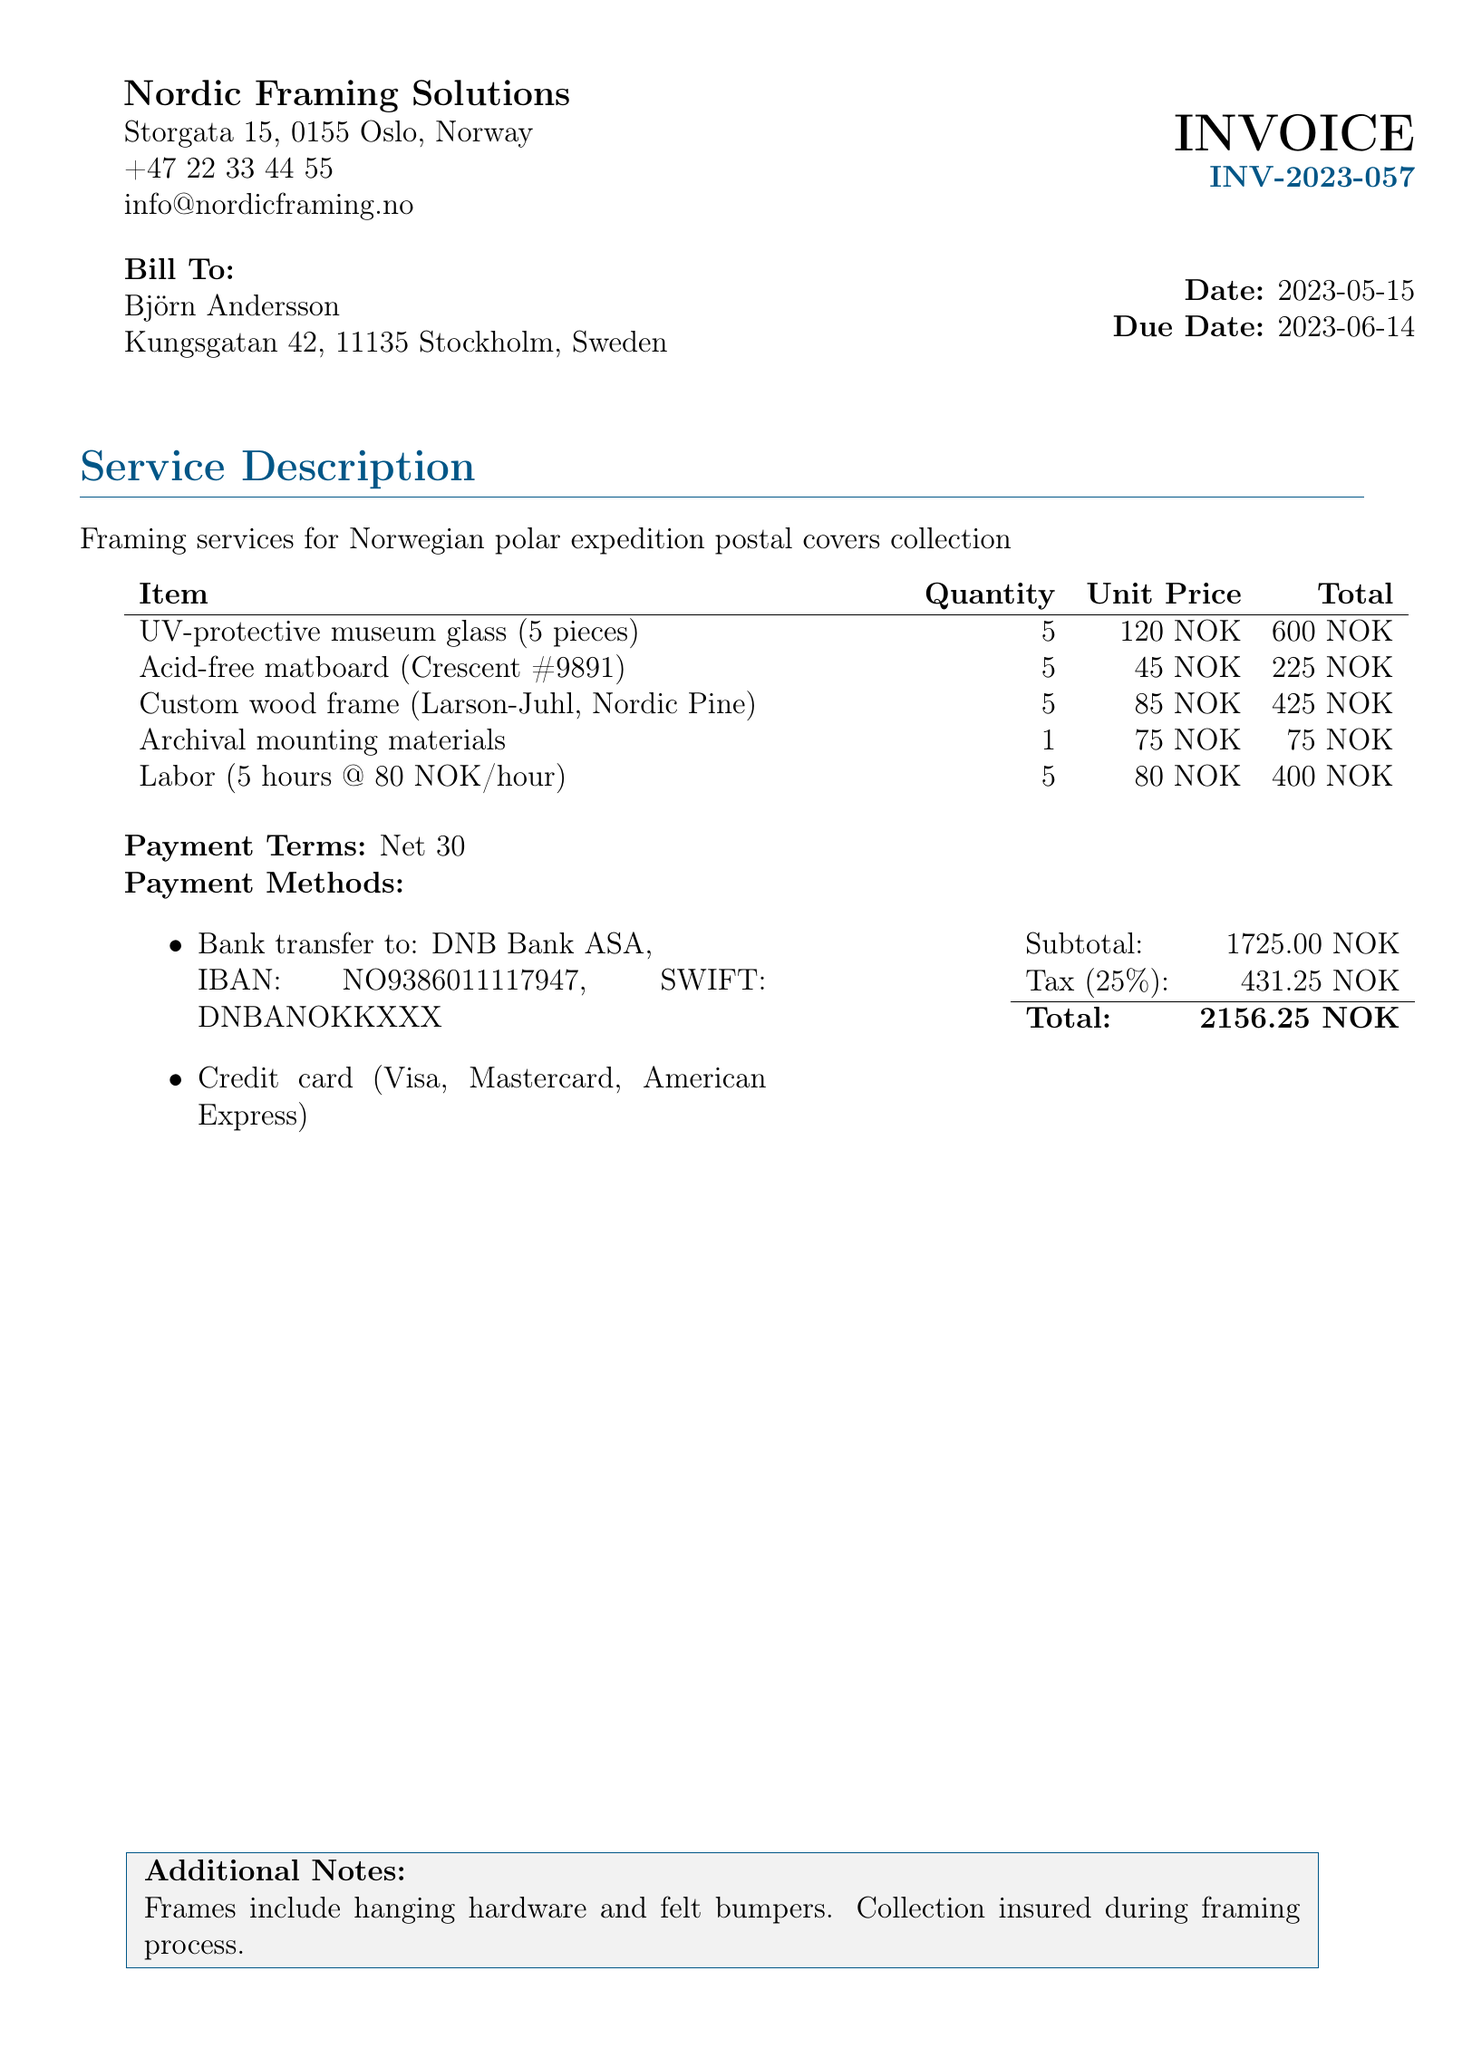What is the invoice number? The invoice number is mentioned in the header section of the document, indicated as "INV-2023-057".
Answer: INV-2023-057 Who is the bill addressed to? The bill is addressed to Björn Andersson, as indicated in the "Bill To" section.
Answer: Björn Andersson What is the subtotal amount? The subtotal is listed right before the tax section, which amounts to 1725.00 NOK.
Answer: 1725.00 NOK What is the tax percentage applied? The tax percentage is clearly stated in the tax section of the document as 25%.
Answer: 25% How many pieces of UV-protective museum glass were included? The quantity for UV-protective museum glass is specified in the itemized list as 5 pieces.
Answer: 5 What is the total amount due? The total is provided at the bottom of the document, combining subtotal and tax, amounting to 2156.25 NOK.
Answer: 2156.25 NOK What payment term is specified? The payment terms are stated as "Net 30" in the payment terms section.
Answer: Net 30 How much is the labor charged per hour? The labor cost per hour is mentioned in the itemized list as 80 NOK.
Answer: 80 NOK What type of frame is used? The custom wood frame specified in the bill is "Larson-Juhl, Nordic Pine".
Answer: Larson-Juhl, Nordic Pine 